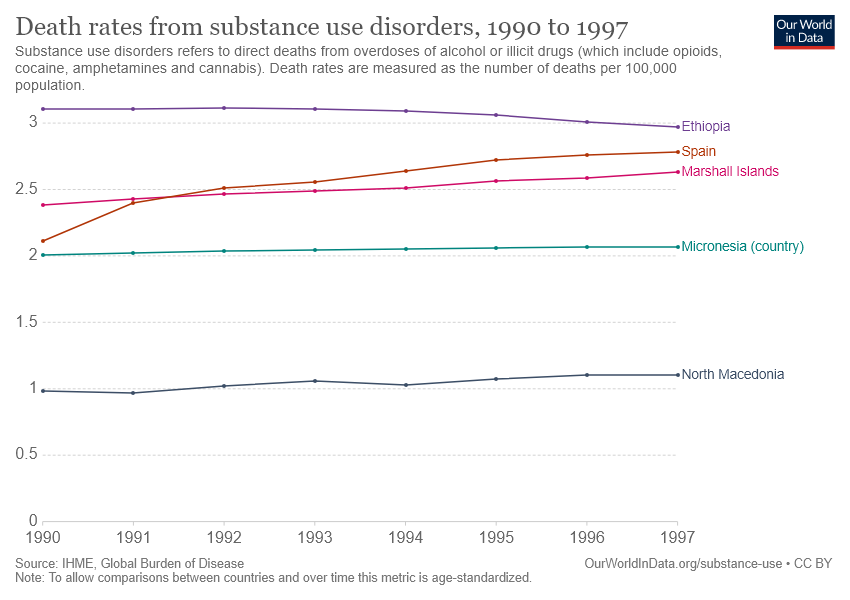Identify some key points in this picture. The number of countries is 5. The value of Spain has been lower than that of the Marshall Islands for a number of years. 